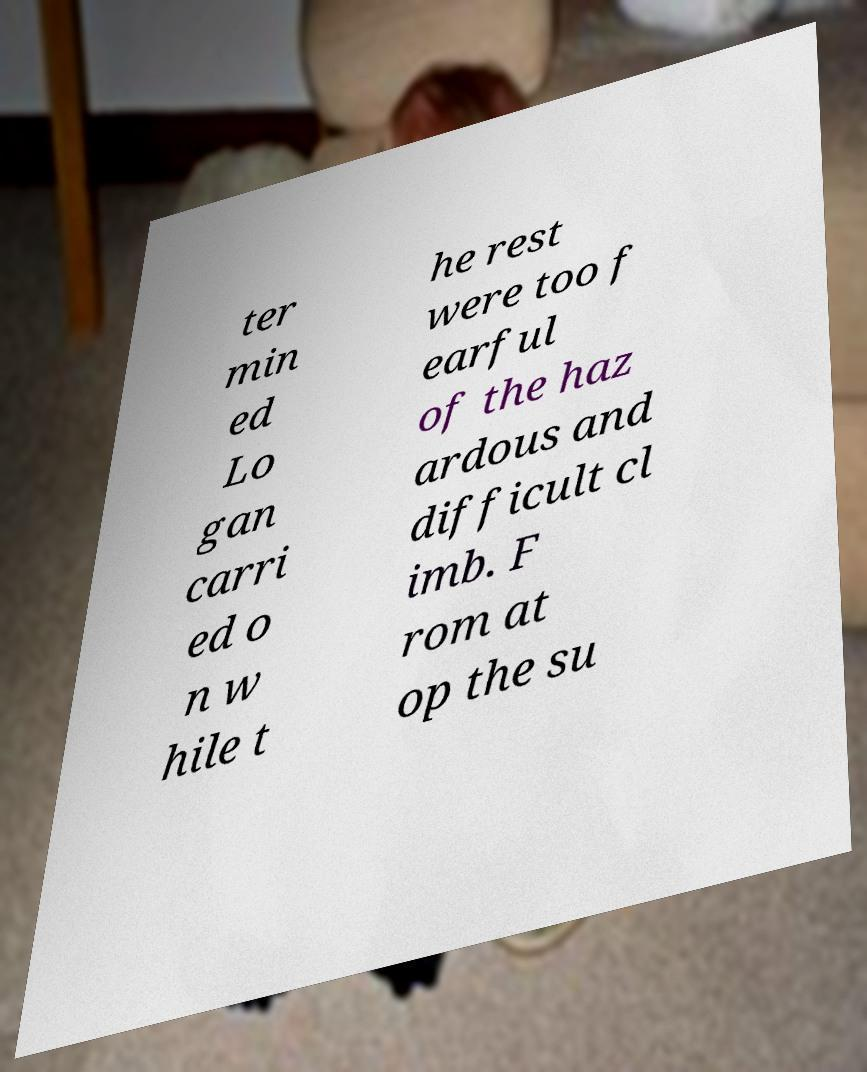For documentation purposes, I need the text within this image transcribed. Could you provide that? ter min ed Lo gan carri ed o n w hile t he rest were too f earful of the haz ardous and difficult cl imb. F rom at op the su 